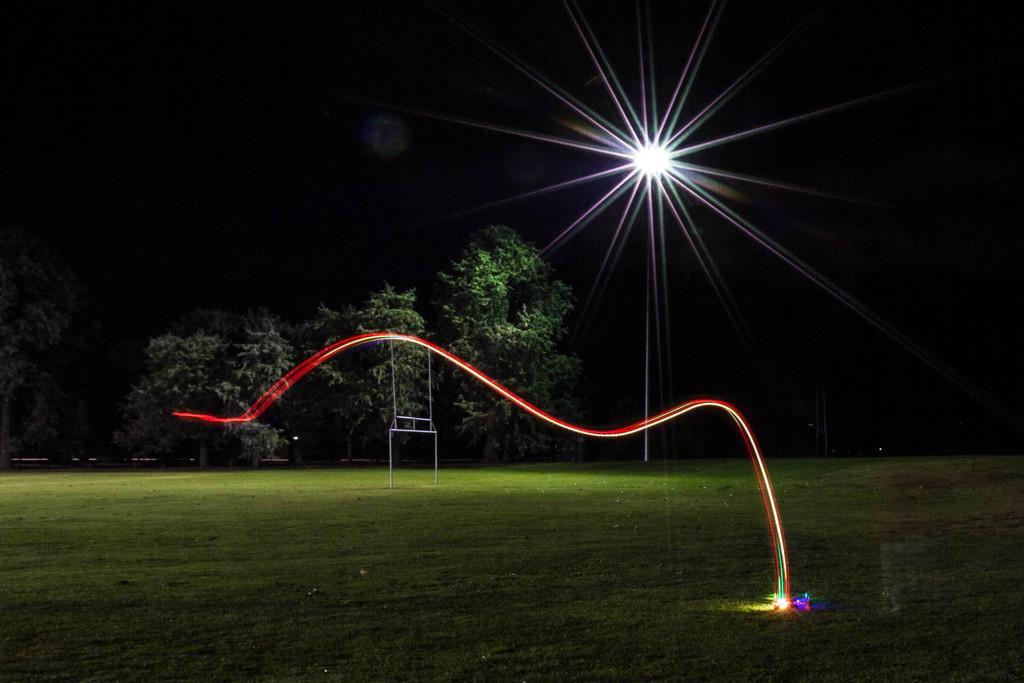Could you give a brief overview of what you see in this image? In this image I can see an open grass ground, number of trees, lights and I can see this image is little bit in dark. 